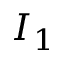Convert formula to latex. <formula><loc_0><loc_0><loc_500><loc_500>I _ { 1 }</formula> 